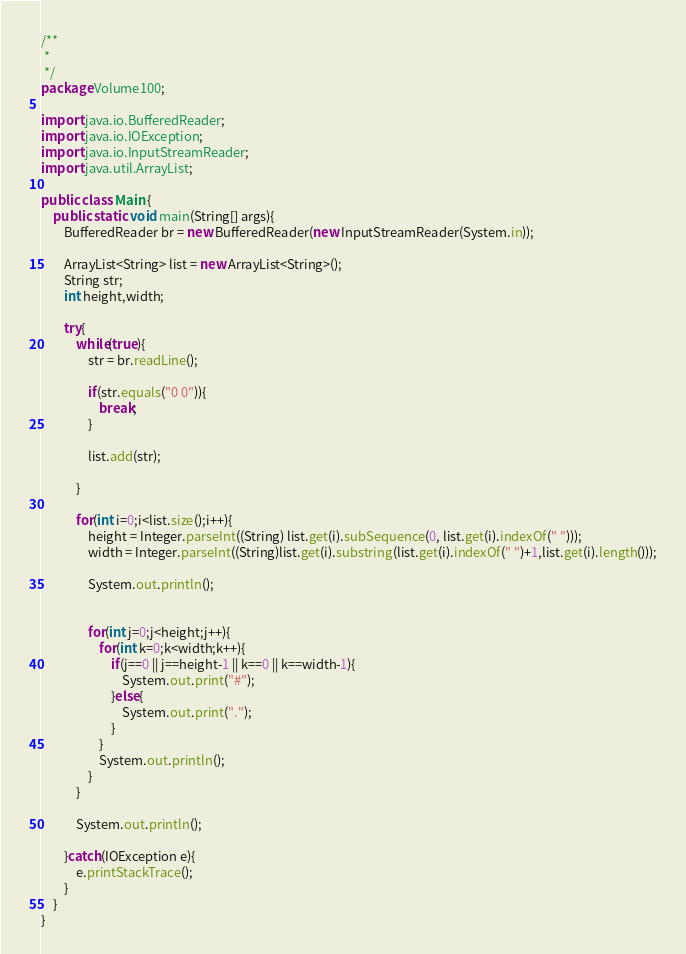<code> <loc_0><loc_0><loc_500><loc_500><_Java_>/**
 *
 */
package Volume100;

import java.io.BufferedReader;
import java.io.IOException;
import java.io.InputStreamReader;
import java.util.ArrayList;

public class Main {
	public static void main(String[] args){
		BufferedReader br = new BufferedReader(new InputStreamReader(System.in));

		ArrayList<String> list = new ArrayList<String>();
		String str;
		int height,width;

		try{
			while(true){
				str = br.readLine();

				if(str.equals("0 0")){
					break;
				}

				list.add(str);

			}

			for(int i=0;i<list.size();i++){
				height = Integer.parseInt((String) list.get(i).subSequence(0, list.get(i).indexOf(" ")));
				width = Integer.parseInt((String)list.get(i).substring(list.get(i).indexOf(" ")+1,list.get(i).length()));

				System.out.println();


				for(int j=0;j<height;j++){
					for(int k=0;k<width;k++){
						if(j==0 || j==height-1 || k==0 || k==width-1){
							System.out.print("#");
						}else{
							System.out.print(".");
						}
					}
					System.out.println();
				}
			}

			System.out.println();

		}catch(IOException e){
			e.printStackTrace();
		}
	}
}</code> 